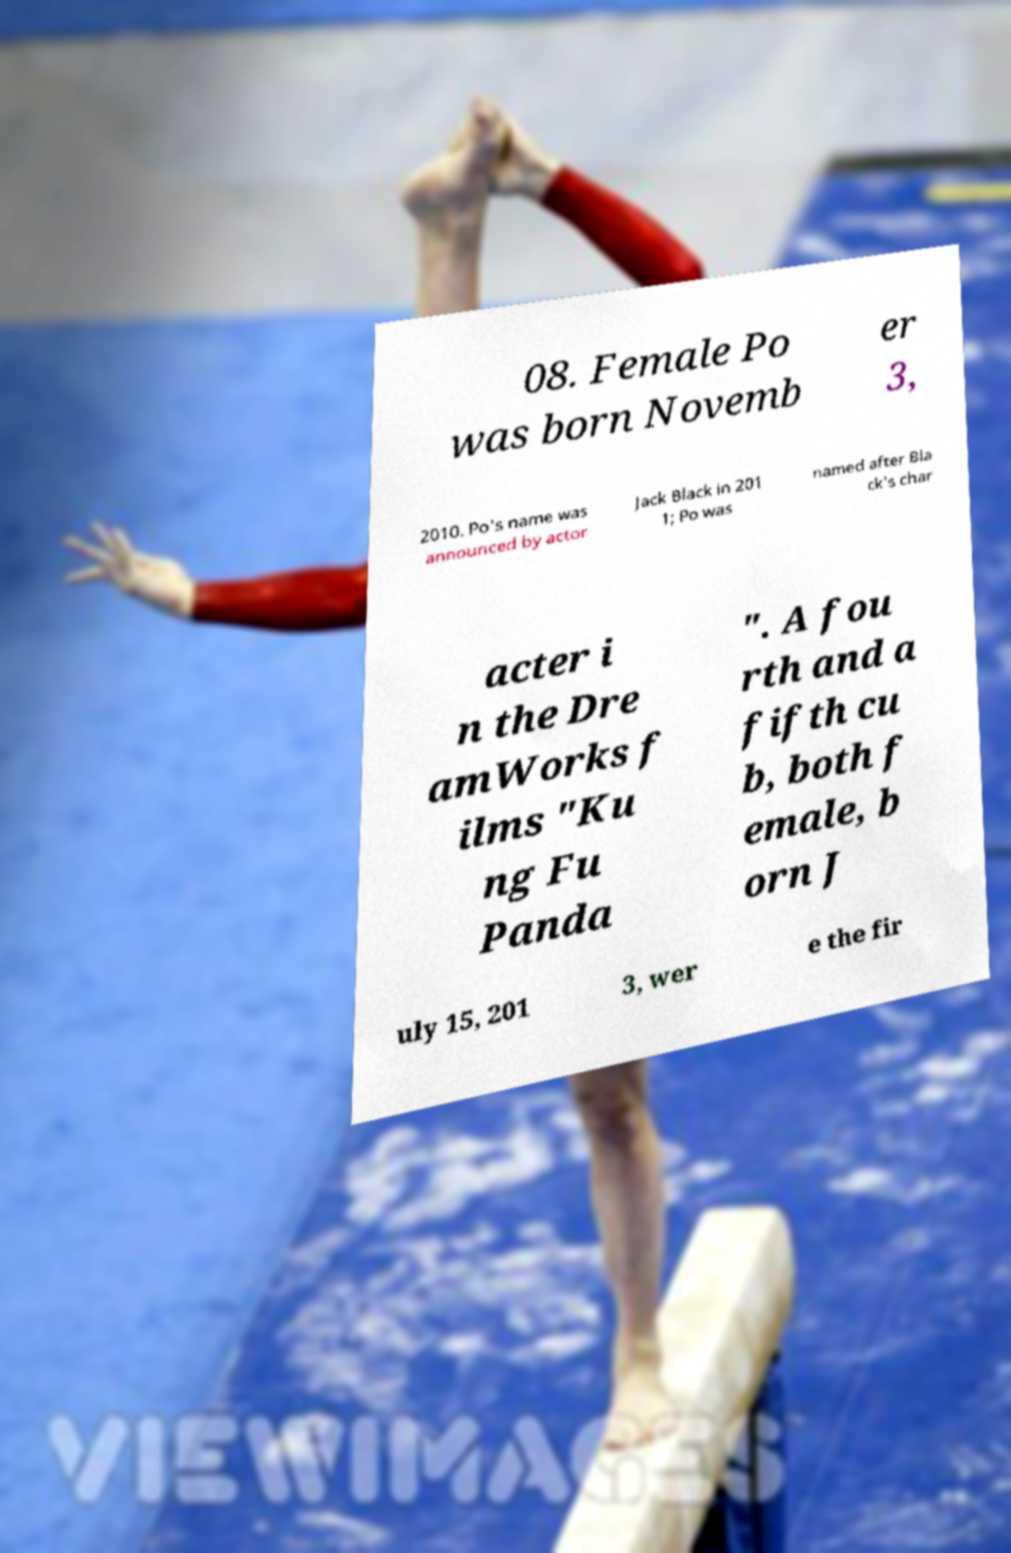Please read and relay the text visible in this image. What does it say? 08. Female Po was born Novemb er 3, 2010. Po's name was announced by actor Jack Black in 201 1; Po was named after Bla ck's char acter i n the Dre amWorks f ilms "Ku ng Fu Panda ". A fou rth and a fifth cu b, both f emale, b orn J uly 15, 201 3, wer e the fir 